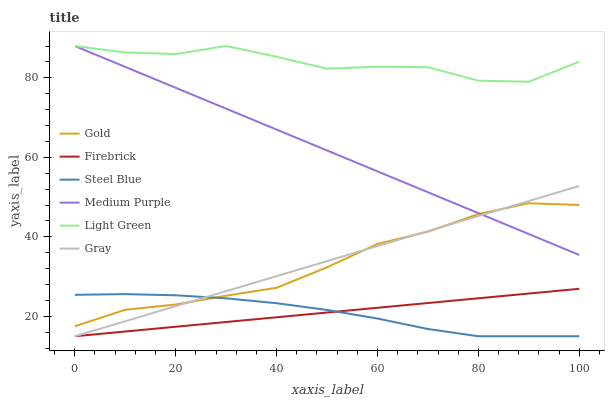Does Steel Blue have the minimum area under the curve?
Answer yes or no. Yes. Does Light Green have the maximum area under the curve?
Answer yes or no. Yes. Does Gold have the minimum area under the curve?
Answer yes or no. No. Does Gold have the maximum area under the curve?
Answer yes or no. No. Is Firebrick the smoothest?
Answer yes or no. Yes. Is Light Green the roughest?
Answer yes or no. Yes. Is Gold the smoothest?
Answer yes or no. No. Is Gold the roughest?
Answer yes or no. No. Does Gray have the lowest value?
Answer yes or no. Yes. Does Gold have the lowest value?
Answer yes or no. No. Does Light Green have the highest value?
Answer yes or no. Yes. Does Gold have the highest value?
Answer yes or no. No. Is Steel Blue less than Light Green?
Answer yes or no. Yes. Is Medium Purple greater than Firebrick?
Answer yes or no. Yes. Does Gold intersect Gray?
Answer yes or no. Yes. Is Gold less than Gray?
Answer yes or no. No. Is Gold greater than Gray?
Answer yes or no. No. Does Steel Blue intersect Light Green?
Answer yes or no. No. 